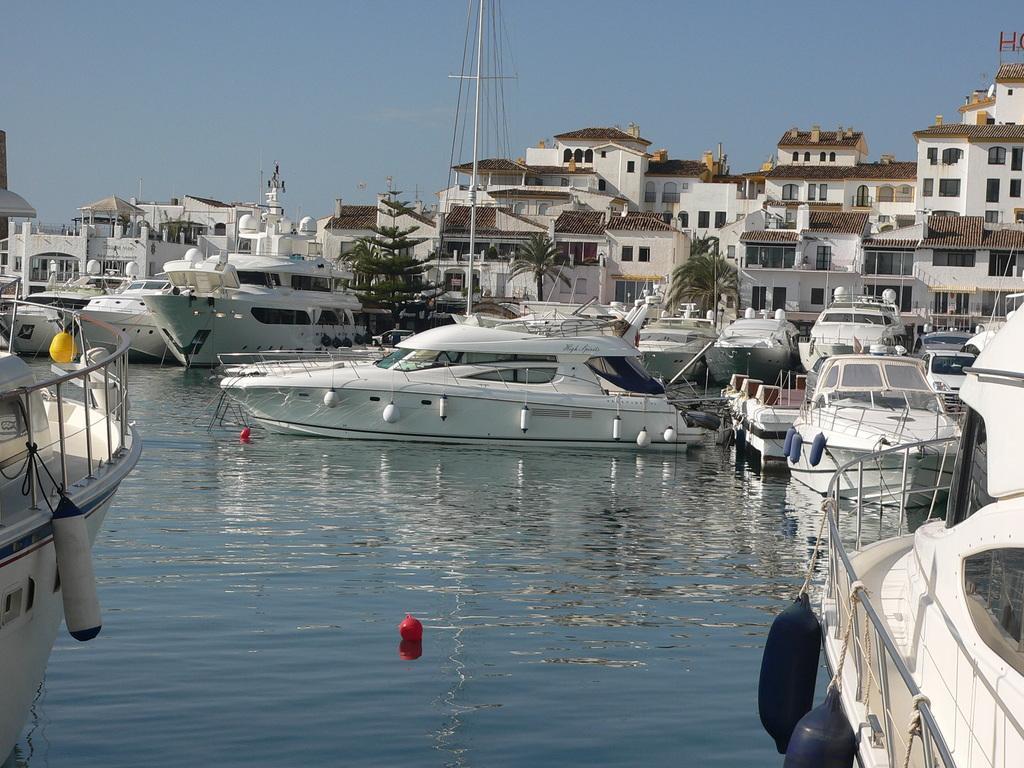In one or two sentences, can you explain what this image depicts? In the picture there is a river and many ships are sailing on the river and behind that there are many beautiful houses. 